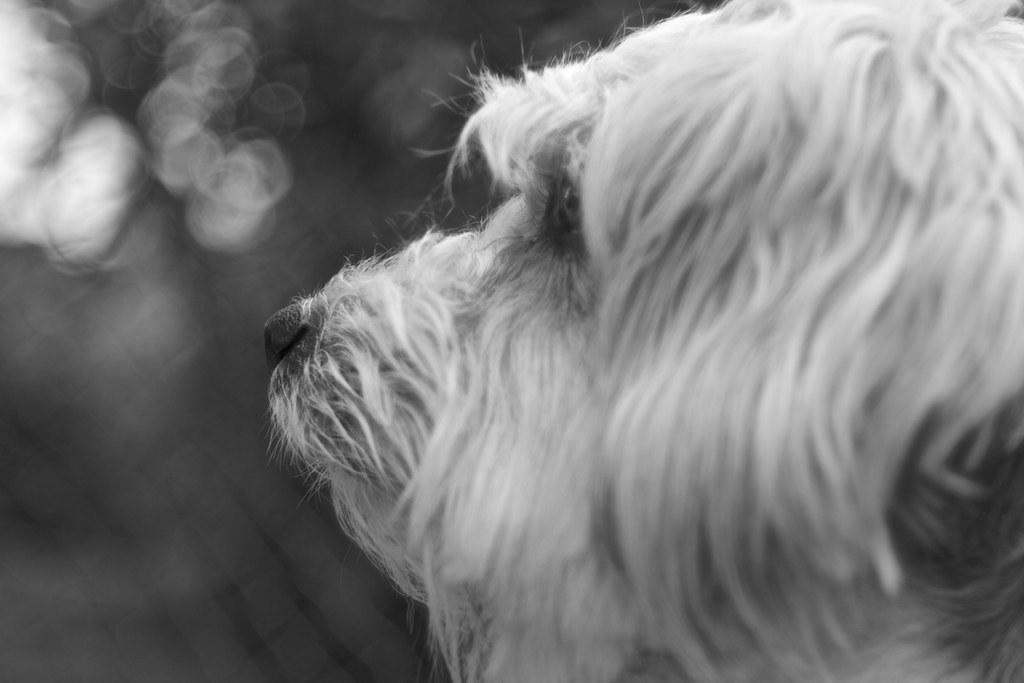What is the color scheme of the image? The image is black and white. What type of animal can be seen in the image? There is a white dog in the image. What color is the background of the image? The background of the image is black in color. How is the background of the image depicted? The background of the image is blurred. What type of crayon is the fireman using to defuse the bomb in the image? There is no fireman, bomb, or crayon present in the image. 